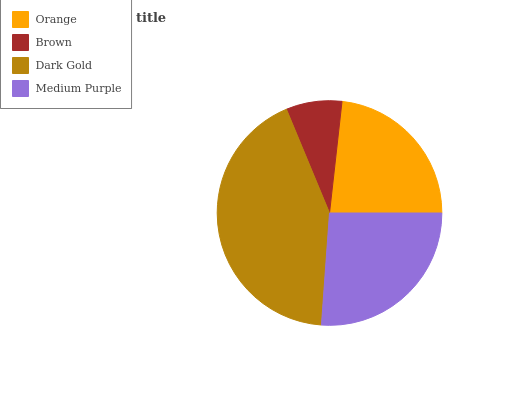Is Brown the minimum?
Answer yes or no. Yes. Is Dark Gold the maximum?
Answer yes or no. Yes. Is Dark Gold the minimum?
Answer yes or no. No. Is Brown the maximum?
Answer yes or no. No. Is Dark Gold greater than Brown?
Answer yes or no. Yes. Is Brown less than Dark Gold?
Answer yes or no. Yes. Is Brown greater than Dark Gold?
Answer yes or no. No. Is Dark Gold less than Brown?
Answer yes or no. No. Is Medium Purple the high median?
Answer yes or no. Yes. Is Orange the low median?
Answer yes or no. Yes. Is Dark Gold the high median?
Answer yes or no. No. Is Medium Purple the low median?
Answer yes or no. No. 